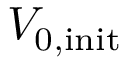<formula> <loc_0><loc_0><loc_500><loc_500>V _ { 0 , i n i t }</formula> 